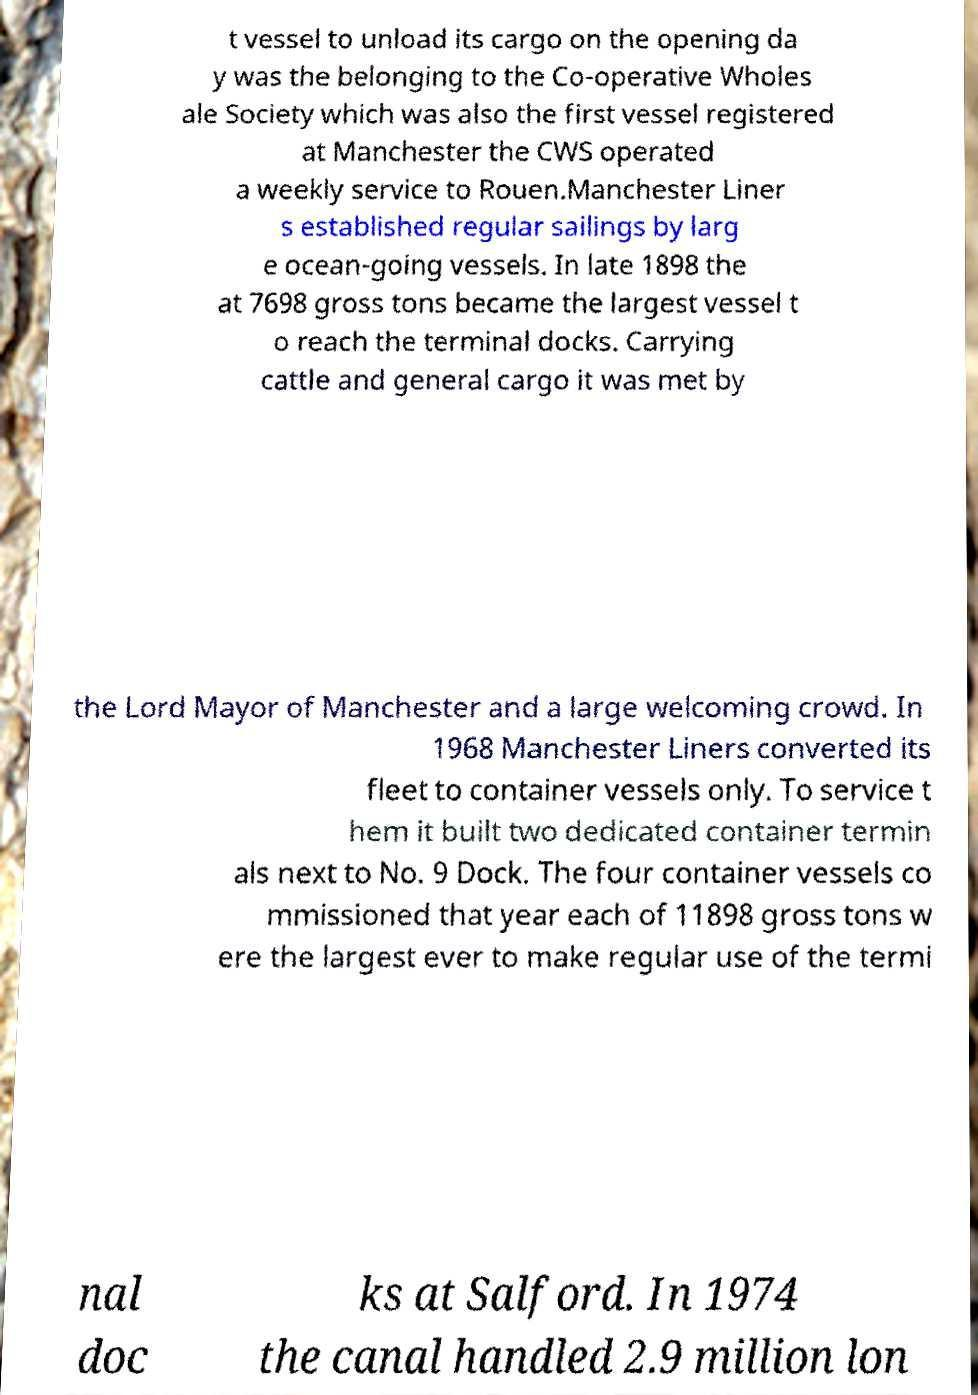What messages or text are displayed in this image? I need them in a readable, typed format. t vessel to unload its cargo on the opening da y was the belonging to the Co-operative Wholes ale Society which was also the first vessel registered at Manchester the CWS operated a weekly service to Rouen.Manchester Liner s established regular sailings by larg e ocean-going vessels. In late 1898 the at 7698 gross tons became the largest vessel t o reach the terminal docks. Carrying cattle and general cargo it was met by the Lord Mayor of Manchester and a large welcoming crowd. In 1968 Manchester Liners converted its fleet to container vessels only. To service t hem it built two dedicated container termin als next to No. 9 Dock. The four container vessels co mmissioned that year each of 11898 gross tons w ere the largest ever to make regular use of the termi nal doc ks at Salford. In 1974 the canal handled 2.9 million lon 